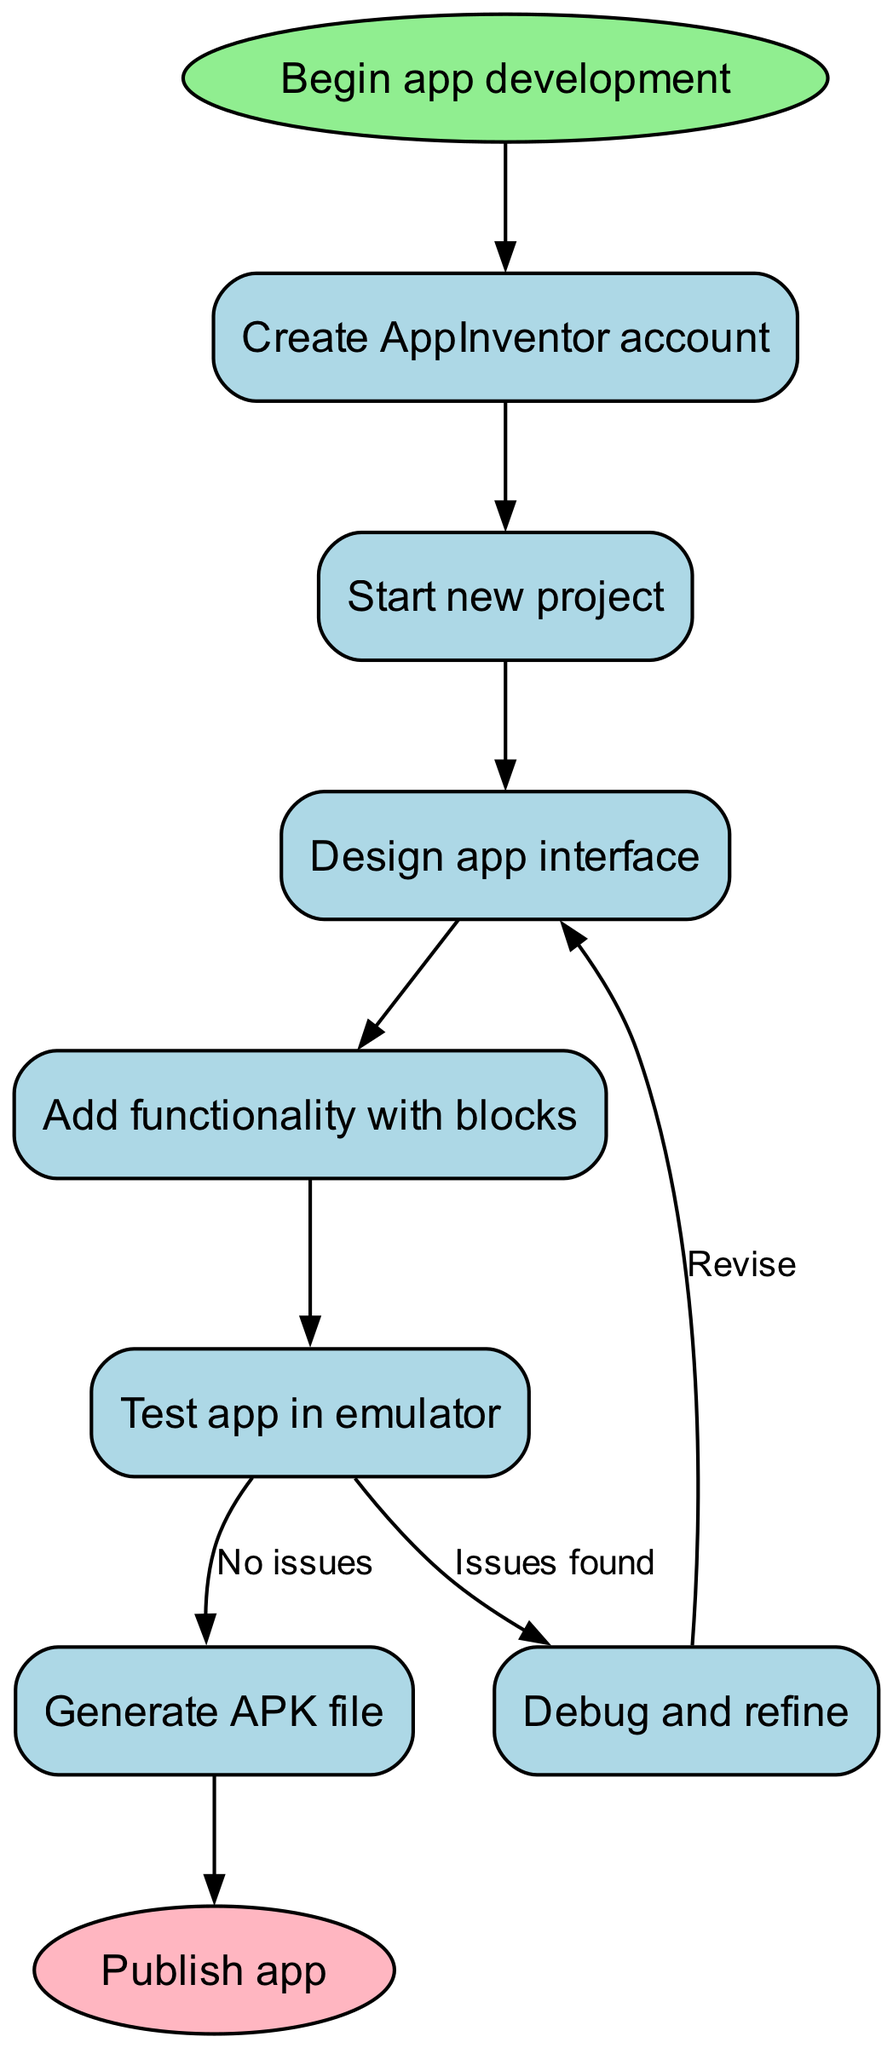What is the first step in the app development process? The first step listed in the flowchart is "Create AppInventor account." It is the node that immediately follows the starting point labeled "Begin app development."
Answer: Create AppInventor account How many nodes are in the flowchart? The flowchart has a total of 8 nodes: 1 starting node, 7 steps for app development, and 1 ending node. Counting up all the nodes gives us 8.
Answer: 8 What step comes after designing the app interface? After "Design app interface," the next step is "Add functionality with blocks." This can be identified from the flow arrows connecting the two nodes.
Answer: Add functionality with blocks What happens if there are issues found during testing? If there are issues found during testing, the flowchart indicates a path leading to "Debug and refine," which suggests revising the app. This is derived from the edge labeled "Issues found" that connects from "Test app in emulator" to "Debug and refine."
Answer: Debug and refine Is there a way to generate the APK file without finding issues? Yes, if no issues are found during the testing phase, the flowchart indicates that one can proceed to "Generate APK file." This is shown by the edge labeled "No issues" connecting from "Test app in emulator" to "Generate APK file."
Answer: Generate APK file What is the final step in the app development process? The final step in the flowchart is "Publish app," which is represented by the end node. This node indicates the completion of the app development process.
Answer: Publish app How are the steps connected in the flowchart? The steps are connected in a linear fashion, where each step leads to the next. The flow follows a sequence from the creation of an account to publishing the app, with specific paths for debugging if issues are encountered. This is observed by following the directed edges between the nodes sequentially throughout the diagram.
Answer: Linear sequence What action should be taken after debugging? After debugging, the flowchart indicates to "Revise" by connecting back to "Design app interface." This means that developers are encouraged to revise their designs following the debugging process.
Answer: Revise 